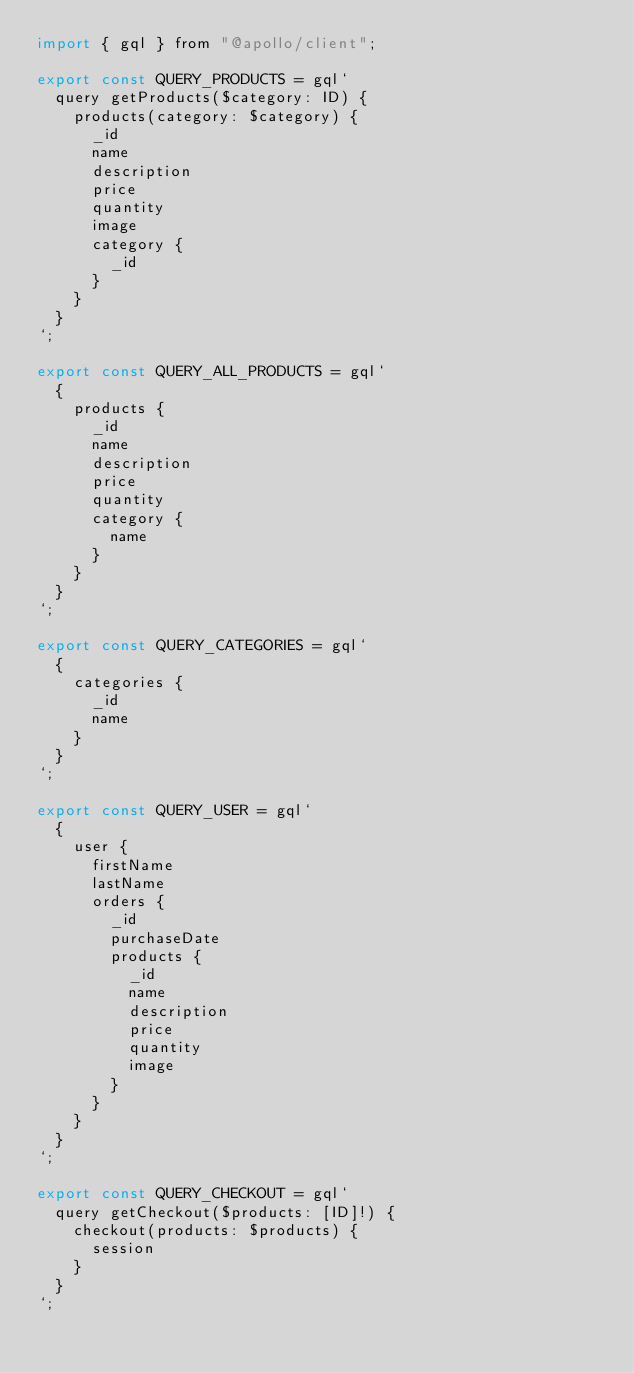<code> <loc_0><loc_0><loc_500><loc_500><_JavaScript_>import { gql } from "@apollo/client";

export const QUERY_PRODUCTS = gql`
  query getProducts($category: ID) {
    products(category: $category) {
      _id
      name
      description
      price
      quantity
      image
      category {
        _id
      }
    }
  }
`;

export const QUERY_ALL_PRODUCTS = gql`
  {
    products {
      _id
      name
      description
      price
      quantity
      category {
        name
      }
    }
  }
`;

export const QUERY_CATEGORIES = gql`
  {
    categories {
      _id
      name
    }
  }
`;

export const QUERY_USER = gql`
  {
    user {
      firstName
      lastName
      orders {
        _id
        purchaseDate
        products {
          _id
          name
          description
          price
          quantity
          image
        }
      }
    }
  }
`;

export const QUERY_CHECKOUT = gql`
  query getCheckout($products: [ID]!) {
    checkout(products: $products) {
      session
    }
  }
`;
</code> 